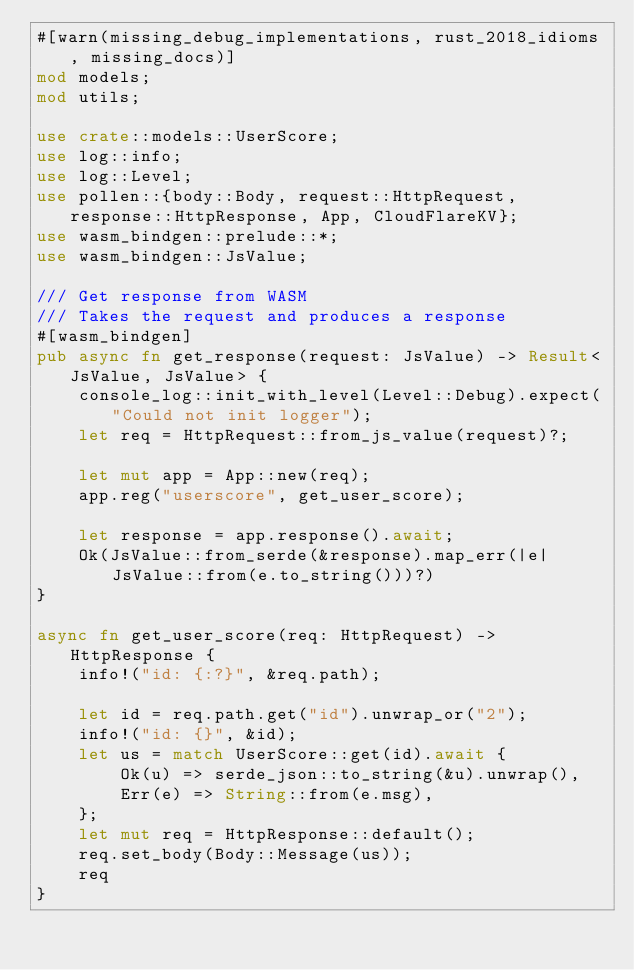Convert code to text. <code><loc_0><loc_0><loc_500><loc_500><_Rust_>#[warn(missing_debug_implementations, rust_2018_idioms, missing_docs)]
mod models;
mod utils;

use crate::models::UserScore;
use log::info;
use log::Level;
use pollen::{body::Body, request::HttpRequest, response::HttpResponse, App, CloudFlareKV};
use wasm_bindgen::prelude::*;
use wasm_bindgen::JsValue;

/// Get response from WASM
/// Takes the request and produces a response
#[wasm_bindgen]
pub async fn get_response(request: JsValue) -> Result<JsValue, JsValue> {
    console_log::init_with_level(Level::Debug).expect("Could not init logger");
    let req = HttpRequest::from_js_value(request)?;

    let mut app = App::new(req);
    app.reg("userscore", get_user_score);

    let response = app.response().await;
    Ok(JsValue::from_serde(&response).map_err(|e| JsValue::from(e.to_string()))?)
}

async fn get_user_score(req: HttpRequest) -> HttpResponse {
    info!("id: {:?}", &req.path);

    let id = req.path.get("id").unwrap_or("2");
    info!("id: {}", &id);
    let us = match UserScore::get(id).await {
        Ok(u) => serde_json::to_string(&u).unwrap(),
        Err(e) => String::from(e.msg),
    };
    let mut req = HttpResponse::default();
    req.set_body(Body::Message(us));
    req
}
</code> 